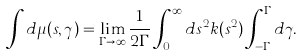Convert formula to latex. <formula><loc_0><loc_0><loc_500><loc_500>\int d \mu ( s , \gamma ) = \lim _ { \Gamma \rightarrow \infty } \frac { 1 } { 2 \Gamma } \int _ { 0 } ^ { \infty } d s ^ { 2 } k ( s ^ { 2 } ) \int _ { - \Gamma } ^ { \Gamma } d \gamma .</formula> 